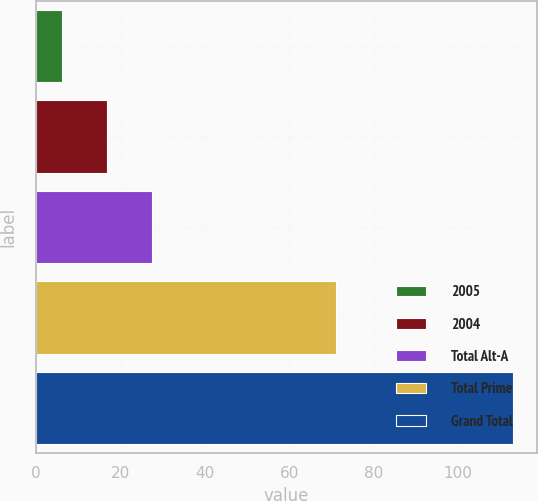Convert chart to OTSL. <chart><loc_0><loc_0><loc_500><loc_500><bar_chart><fcel>2005<fcel>2004<fcel>Total Alt-A<fcel>Total Prime<fcel>Grand Total<nl><fcel>6<fcel>16.7<fcel>27.4<fcel>71<fcel>113<nl></chart> 